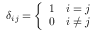<formula> <loc_0><loc_0><loc_500><loc_500>\delta _ { i j } = { \left \{ \begin{array} { l l } { 1 } & { i = j } \\ { 0 } & { i \not = j } \end{array} }</formula> 